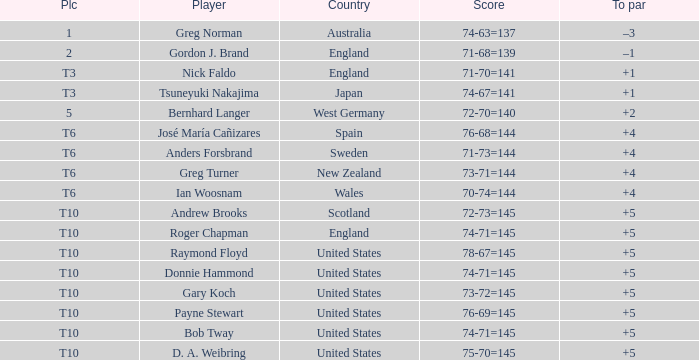Which player scored 76-68=144? José María Cañizares. 